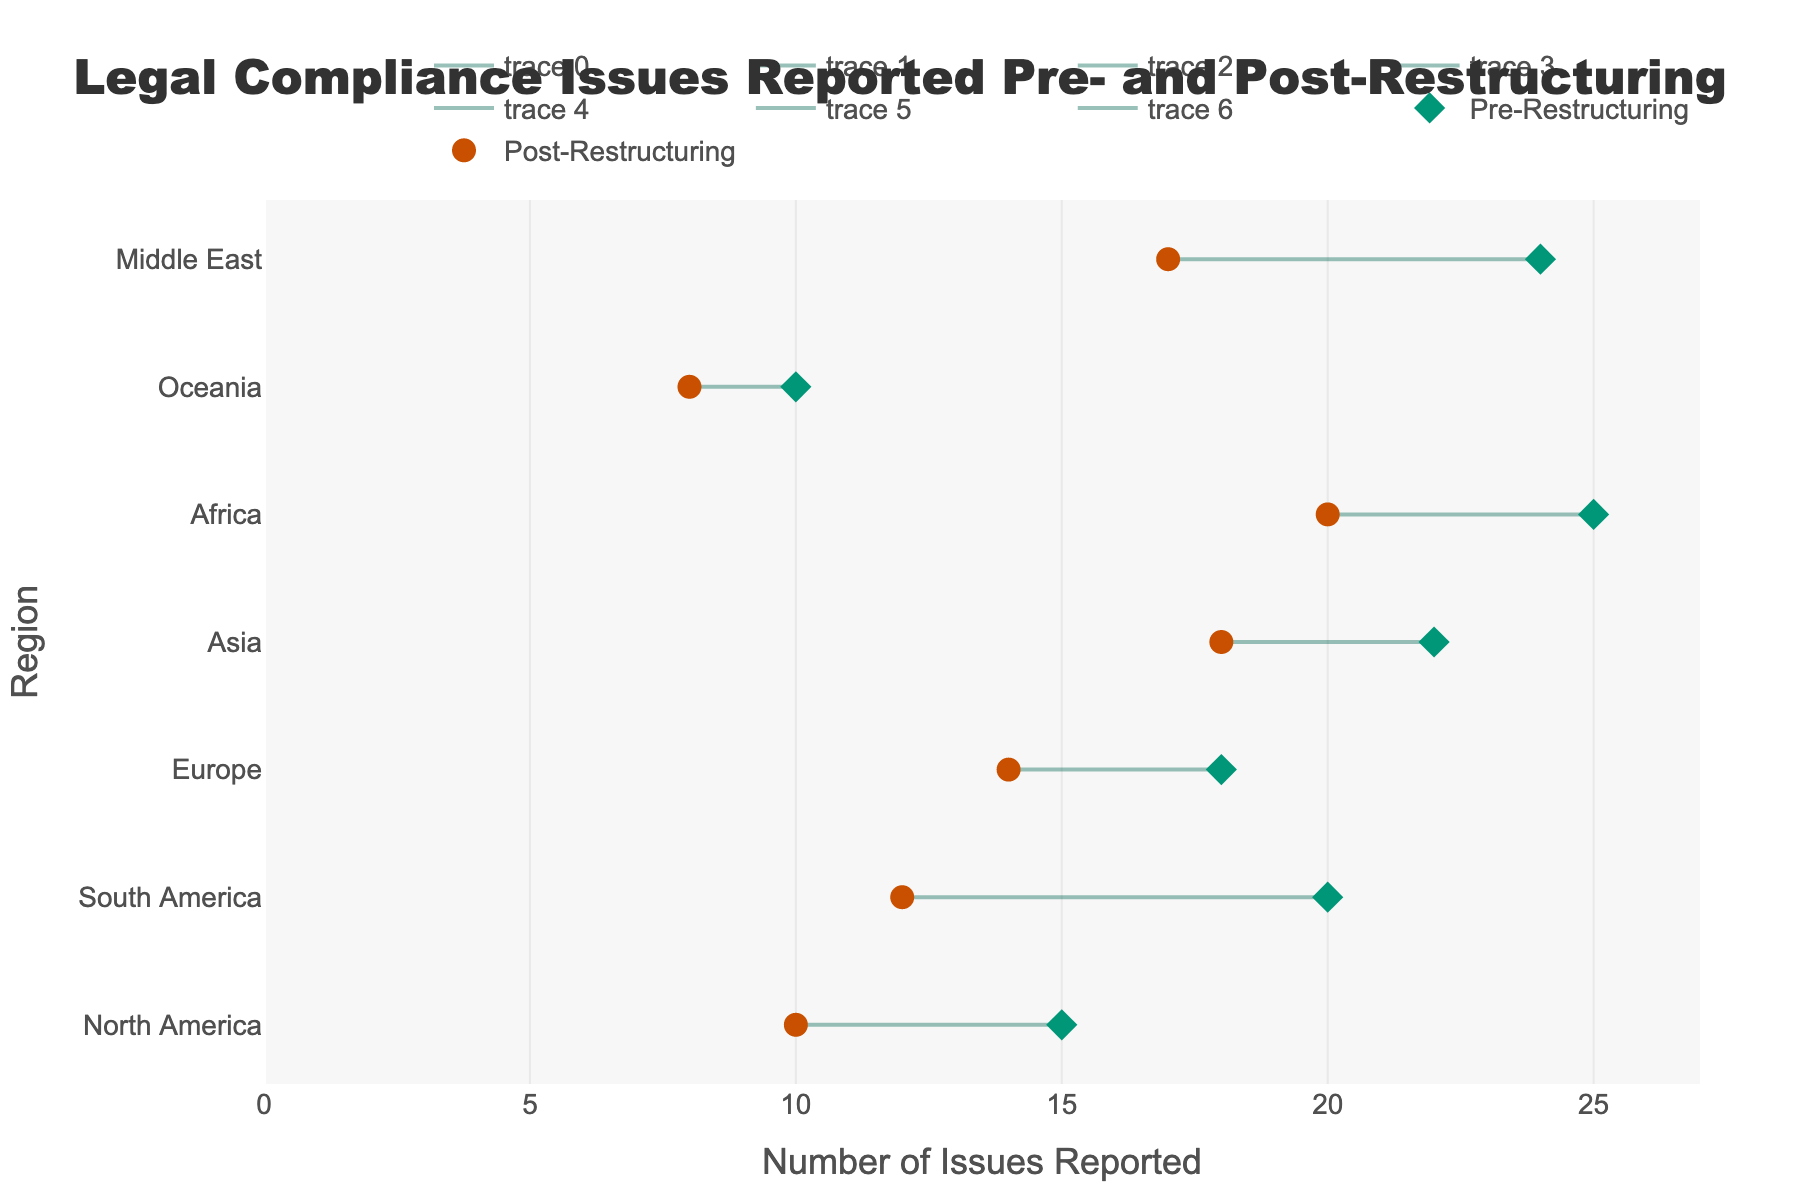What is the title of the figure? The title is typically found at the top of the figure, usually centered and in a larger font size to distinguish it from other text elements. In this case, it states the main subject of the plot.
Answer: Legal Compliance Issues Reported Pre- and Post-Restructuring Which region had the highest number of legal compliance issues pre-restructuring? Look at the horizontal markers tagged as "Pre-Restructuring" on the figure. Identify the region that aligns with the largest number on the x-axis.
Answer: Africa How many issues were reported in Europe post-restructuring? Find Europe on the y-axis and identify the marker corresponding to "Post-Restructuring". Check the x-axis value where this marker is located.
Answer: 14 What is the difference in reported issues for South America between pre- and post-restructuring? Locate South America on the y-axis. Note the positions of both the "Pre-Restructuring" and "Post-Restructuring" markers on the x-axis, then subtract the latter from the former.
Answer: 8 Which region saw the largest reduction in legal compliance issues after restructuring? Compare the horizontal distances between "Pre-Restructuring" and "Post-Restructuring" markers for each region. The largest reduction corresponds to the widest gap.
Answer: Middle East Were there any regions where the number of issues decreased by 5 units or more? Examine the reductions in legal compliance issues for each region by comparing the "Pre-Restructuring" and "Post-Restructuring" markers along the x-axis. Locate regions where the decrease is at least 5.
Answer: Yes (North America, South America, Africa, Middle East) What is the range of reported issues post-restructuring? Identify the smallest and largest x-axis values corresponding to the "Post-Restructuring" markers, then calculate the range by subtracting the smallest value from the largest value.
Answer: 12 (8 to 20) How many regions have fewer than 18 issues post-restructuring? Locate the "Post-Restructuring" markers on the x-axis and count those that are positioned at less than 18 units.
Answer: 5 regions Does any region have the same number of issues pre- and post-restructuring? Compare the "Pre-Restructuring" and "Post-Restructuring" markers for all regions to check for overlaps on the x-axis.
Answer: No In which region did restructuring have the least impact on the number of legal compliance issues? Look for the smallest horizontal distance between the "Pre-Restructuring" and "Post-Restructuring" markers. This indicates the least change (or impact).
Answer: Oceania 